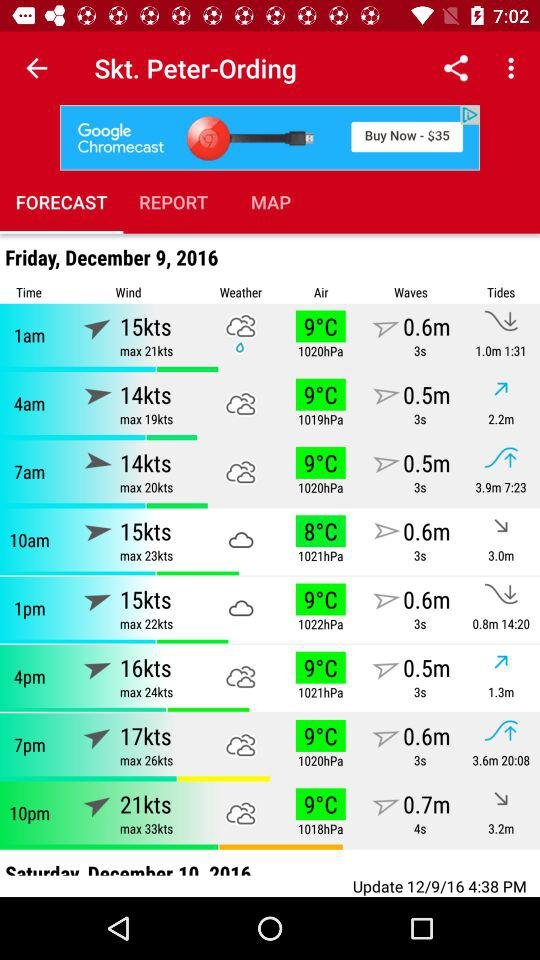What is the application name?
When the provided information is insufficient, respond with <no answer>. <no answer> 